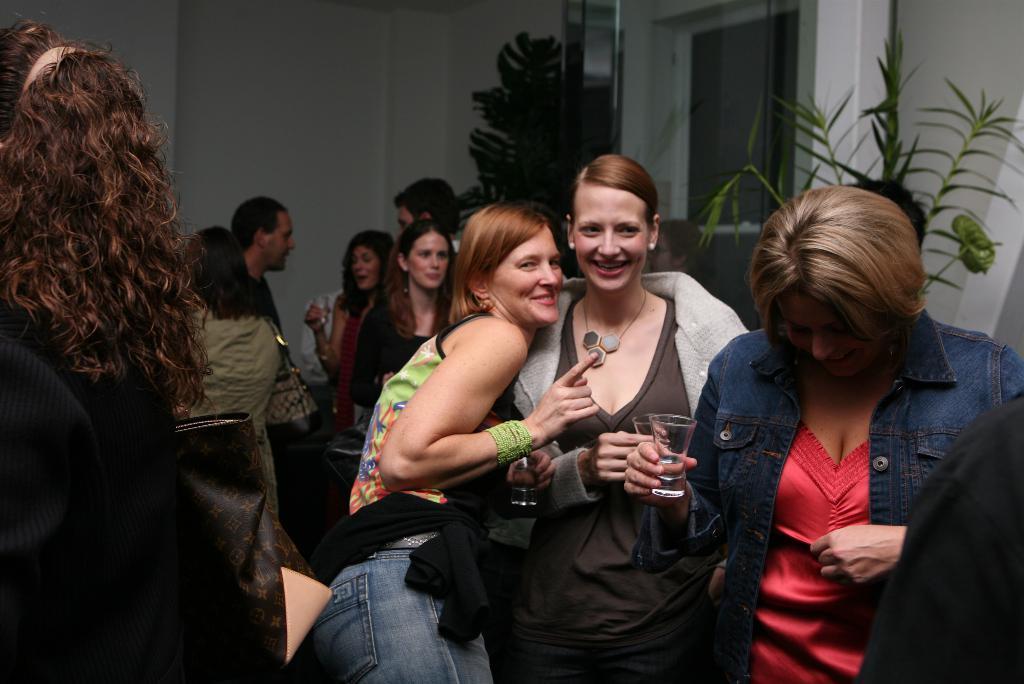Can you describe this image briefly? As we can see in the image there is a wall, plants, few people standing here and there and holding glasses. 